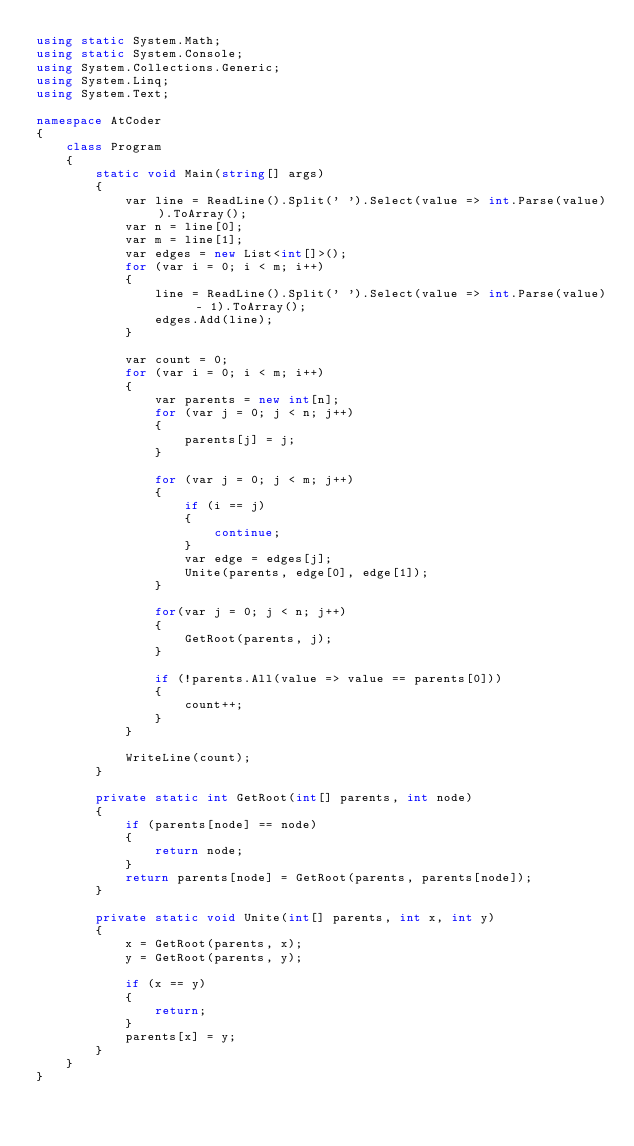<code> <loc_0><loc_0><loc_500><loc_500><_C#_>using static System.Math;
using static System.Console;
using System.Collections.Generic;
using System.Linq;
using System.Text;

namespace AtCoder
{
    class Program
    {
        static void Main(string[] args)
        {
            var line = ReadLine().Split(' ').Select(value => int.Parse(value)).ToArray();
            var n = line[0];
            var m = line[1];
            var edges = new List<int[]>();
            for (var i = 0; i < m; i++)
            {
                line = ReadLine().Split(' ').Select(value => int.Parse(value) - 1).ToArray();
                edges.Add(line);
            }

            var count = 0;
            for (var i = 0; i < m; i++)
            {
                var parents = new int[n];
                for (var j = 0; j < n; j++)
                {
                    parents[j] = j;
                }

                for (var j = 0; j < m; j++)
                {
                    if (i == j)
                    {
                        continue;
                    }
                    var edge = edges[j];
                    Unite(parents, edge[0], edge[1]);
                }

                for(var j = 0; j < n; j++)
                {
                    GetRoot(parents, j);
                }

                if (!parents.All(value => value == parents[0]))
                {
                    count++;
                }
            }

            WriteLine(count);
        }

        private static int GetRoot(int[] parents, int node)
        {
            if (parents[node] == node)
            {
                return node;
            }
            return parents[node] = GetRoot(parents, parents[node]);
        }

        private static void Unite(int[] parents, int x, int y)
        {
            x = GetRoot(parents, x);
            y = GetRoot(parents, y);

            if (x == y)
            {
                return;
            }
            parents[x] = y;
        }
    }
}
</code> 